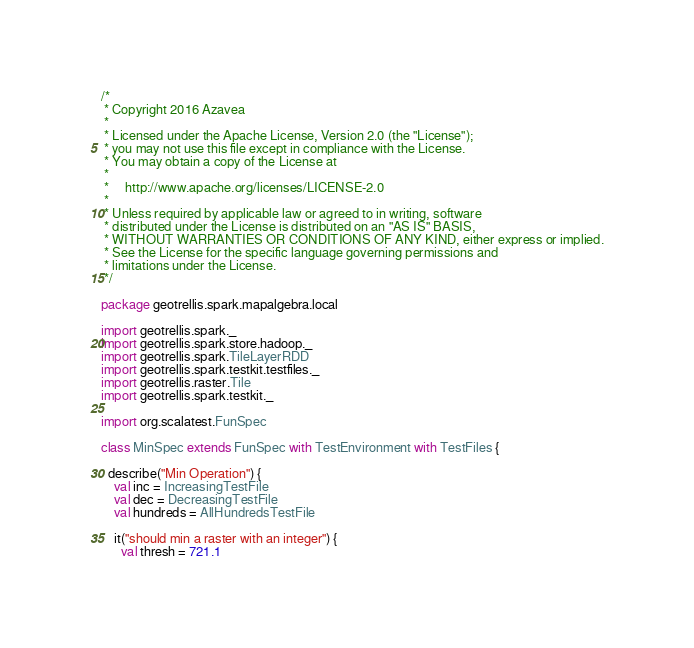Convert code to text. <code><loc_0><loc_0><loc_500><loc_500><_Scala_>/*
 * Copyright 2016 Azavea
 *
 * Licensed under the Apache License, Version 2.0 (the "License");
 * you may not use this file except in compliance with the License.
 * You may obtain a copy of the License at
 *
 *     http://www.apache.org/licenses/LICENSE-2.0
 *
 * Unless required by applicable law or agreed to in writing, software
 * distributed under the License is distributed on an "AS IS" BASIS,
 * WITHOUT WARRANTIES OR CONDITIONS OF ANY KIND, either express or implied.
 * See the License for the specific language governing permissions and
 * limitations under the License.
 */

package geotrellis.spark.mapalgebra.local

import geotrellis.spark._
import geotrellis.spark.store.hadoop._
import geotrellis.spark.TileLayerRDD
import geotrellis.spark.testkit.testfiles._
import geotrellis.raster.Tile
import geotrellis.spark.testkit._

import org.scalatest.FunSpec

class MinSpec extends FunSpec with TestEnvironment with TestFiles {

  describe("Min Operation") {
    val inc = IncreasingTestFile
    val dec = DecreasingTestFile
    val hundreds = AllHundredsTestFile

    it("should min a raster with an integer") {
      val thresh = 721.1</code> 